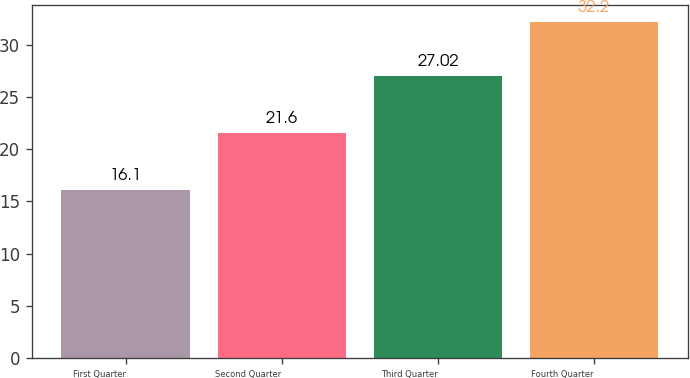<chart> <loc_0><loc_0><loc_500><loc_500><bar_chart><fcel>First Quarter<fcel>Second Quarter<fcel>Third Quarter<fcel>Fourth Quarter<nl><fcel>16.1<fcel>21.6<fcel>27.02<fcel>32.2<nl></chart> 